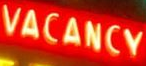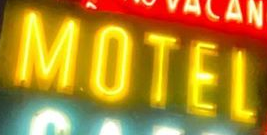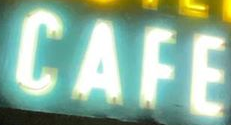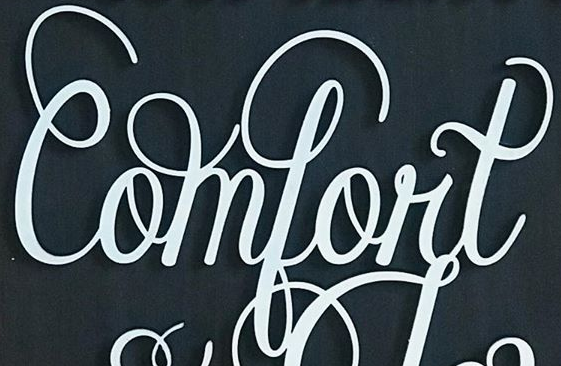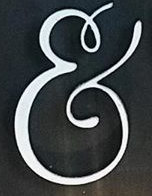Transcribe the words shown in these images in order, separated by a semicolon. VACANCY; MOTEL; CAFE; Comfort; & 